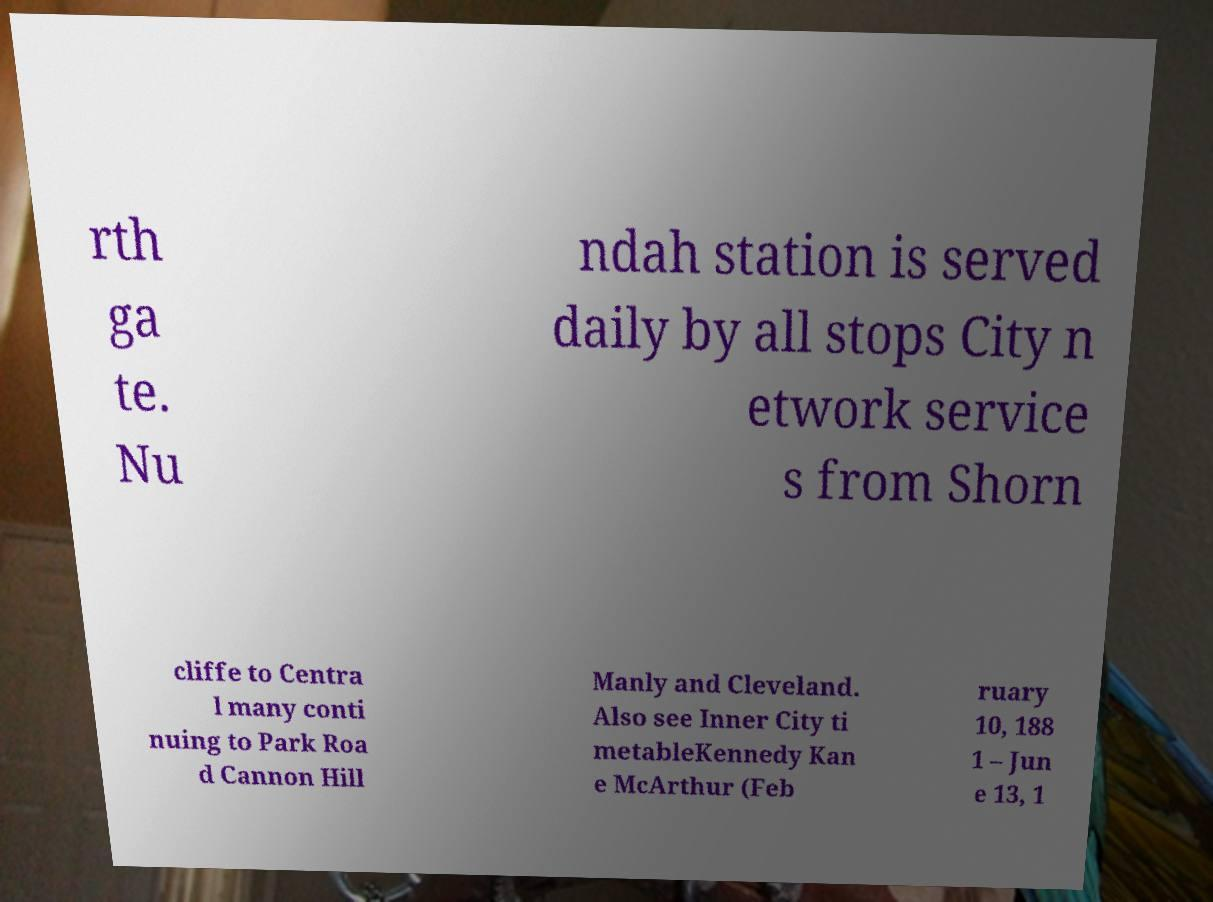Can you accurately transcribe the text from the provided image for me? rth ga te. Nu ndah station is served daily by all stops City n etwork service s from Shorn cliffe to Centra l many conti nuing to Park Roa d Cannon Hill Manly and Cleveland. Also see Inner City ti metableKennedy Kan e McArthur (Feb ruary 10, 188 1 – Jun e 13, 1 